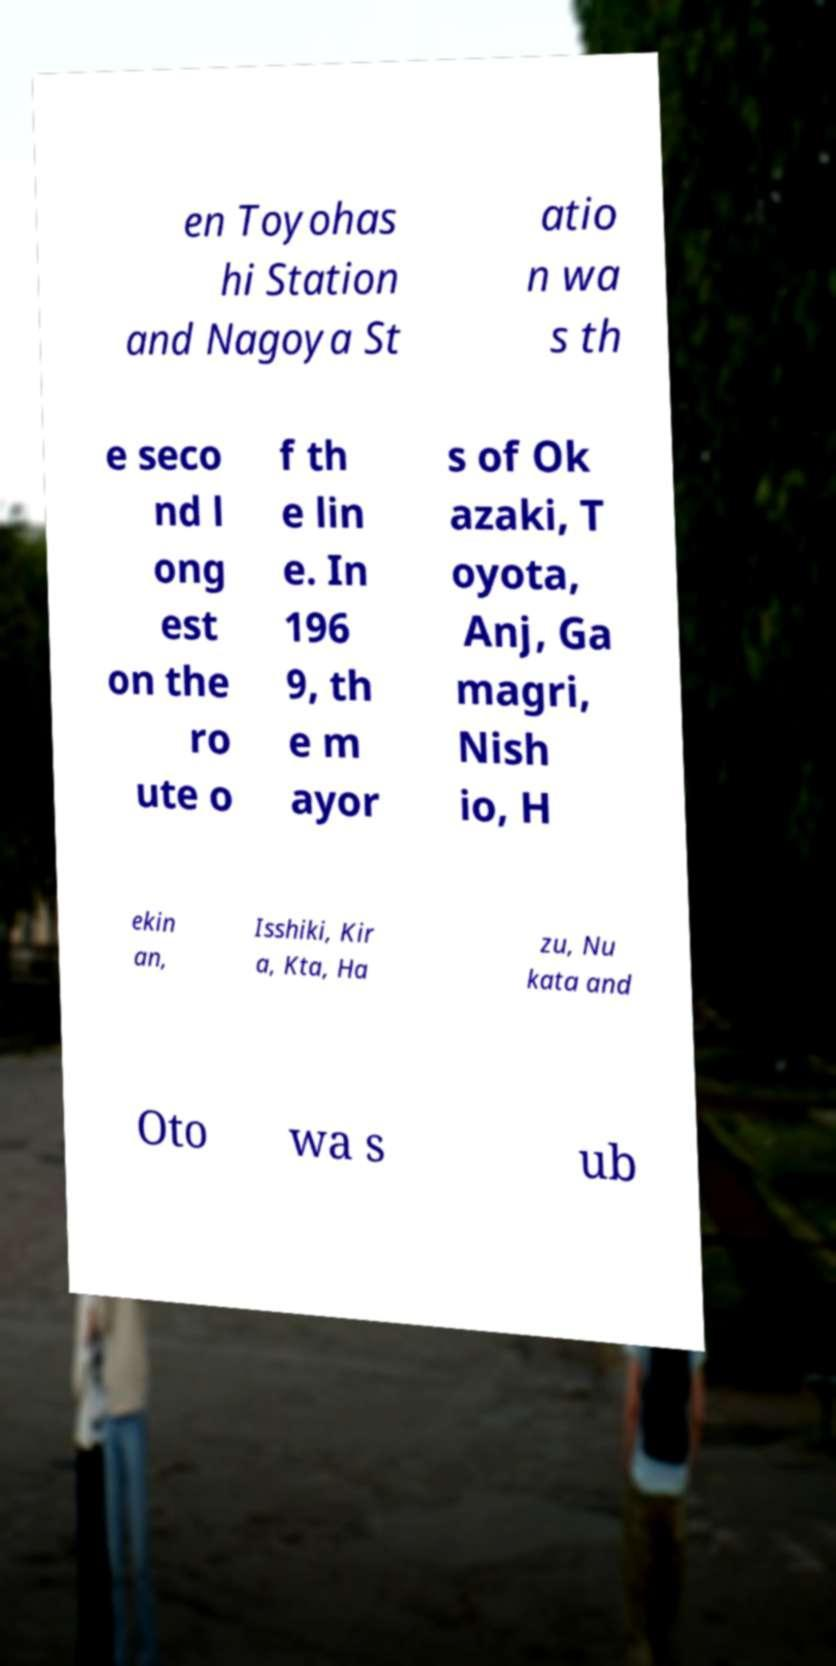Please read and relay the text visible in this image. What does it say? en Toyohas hi Station and Nagoya St atio n wa s th e seco nd l ong est on the ro ute o f th e lin e. In 196 9, th e m ayor s of Ok azaki, T oyota, Anj, Ga magri, Nish io, H ekin an, Isshiki, Kir a, Kta, Ha zu, Nu kata and Oto wa s ub 